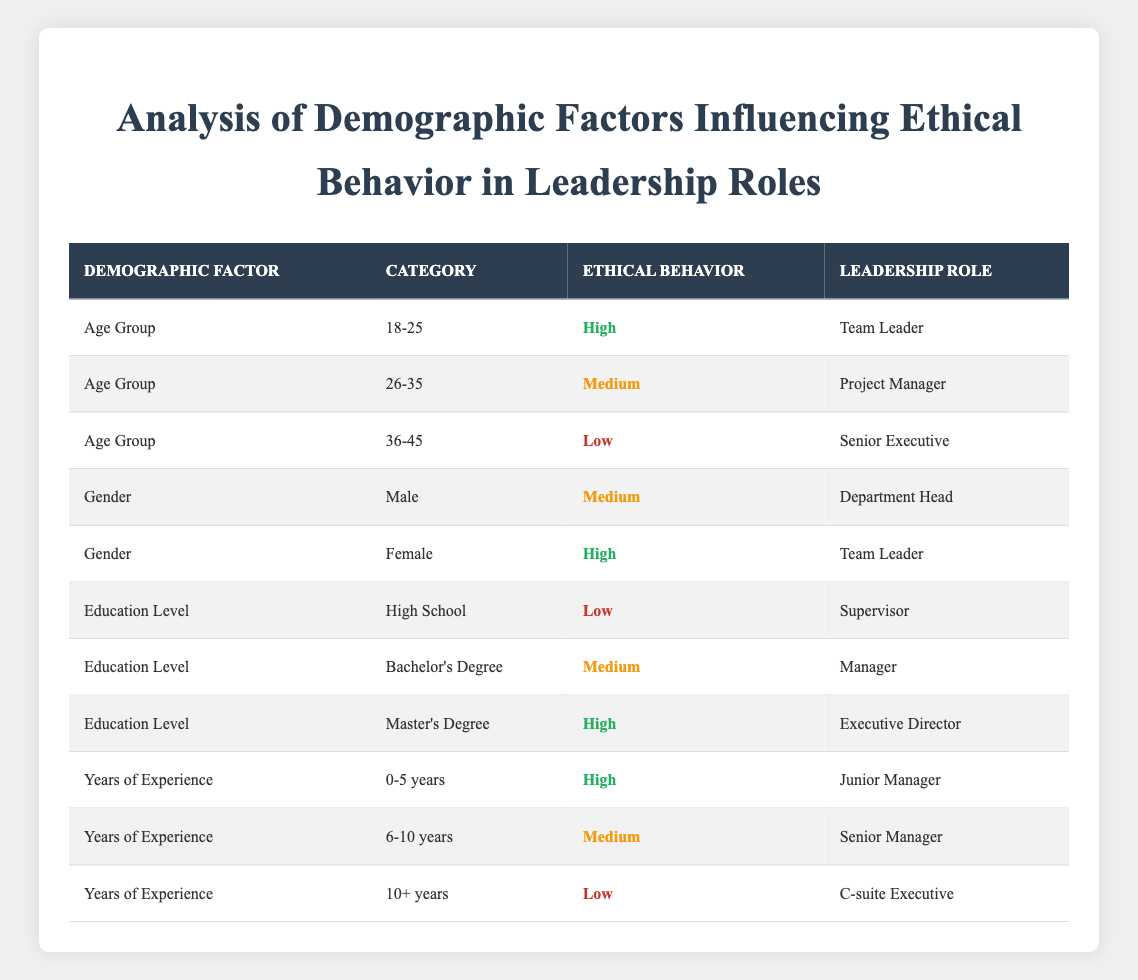What age group has the highest ethical behavior associated with leadership roles? The table indicates that the age group "18-25" is associated with "High" ethical behavior and the leadership role of "Team Leader."
Answer: 18-25 Does being female lead to higher ethical behavior in leadership roles compared to being male? According to the table, females have "High" ethical behavior in the "Team Leader" role, while males are rated "Medium" in the "Department Head" role, suggesting that female leaders tend to exhibit higher ethical behavior.
Answer: Yes What is the ethical behavior rating for executives with 10 or more years of experience? The table shows that those with "10+ years" of experience have a "Low" ethical behavior rating in their roles as "C-suite Executives."
Answer: Low How many demographic factors show a high ethical behavior rating? From the table, the factors "Age Group" (18-25), "Gender" (Female), "Education Level" (Master's Degree), and "Years of Experience" (0-5 years) each show high ethical behavior. This results in a total of four factors.
Answer: 4 Is the ethical behavior of a person with a Bachelor's Degree likely to be higher than that of someone with a High School education? Comparing the table, the ethical behavior rating for a Bachelor's Degree is "Medium," while for a High School education, it is "Low." Thus, individuals with a Bachelor's Degree exhibit higher ethical behavior.
Answer: Yes What is the ethical behavior rating of Senior Managers regarding their years of experience? The table indicates that Senior Managers, who fall under the "6-10 years" category of experience, have a "Medium" ethical behavior rating.
Answer: Medium What leadership role has the highest ethical behavior rating and what demographic factor does it belong to? The leadership role with the highest ethical behavior rating is "Executive Director," associated with the demographic factor "Education Level" and a category of "Master's Degree."
Answer: Executive Director, Education Level Calculate the number of leadership roles associated with each ethical behavior rating. The table lists three ratings: High has 4 roles, Medium has 4 roles, and Low has 3 roles. Therefore, the count is High: 4, Medium: 4, Low: 3.
Answer: High: 4, Medium: 4, Low: 3 Is it true that all individuals with a Master's Degree demonstrate high ethical behavior in leadership roles? The table shows that those with a Master's Degree have "High" ethical behavior as Executive Directors, so it is true for that specific leadership role.
Answer: Yes 